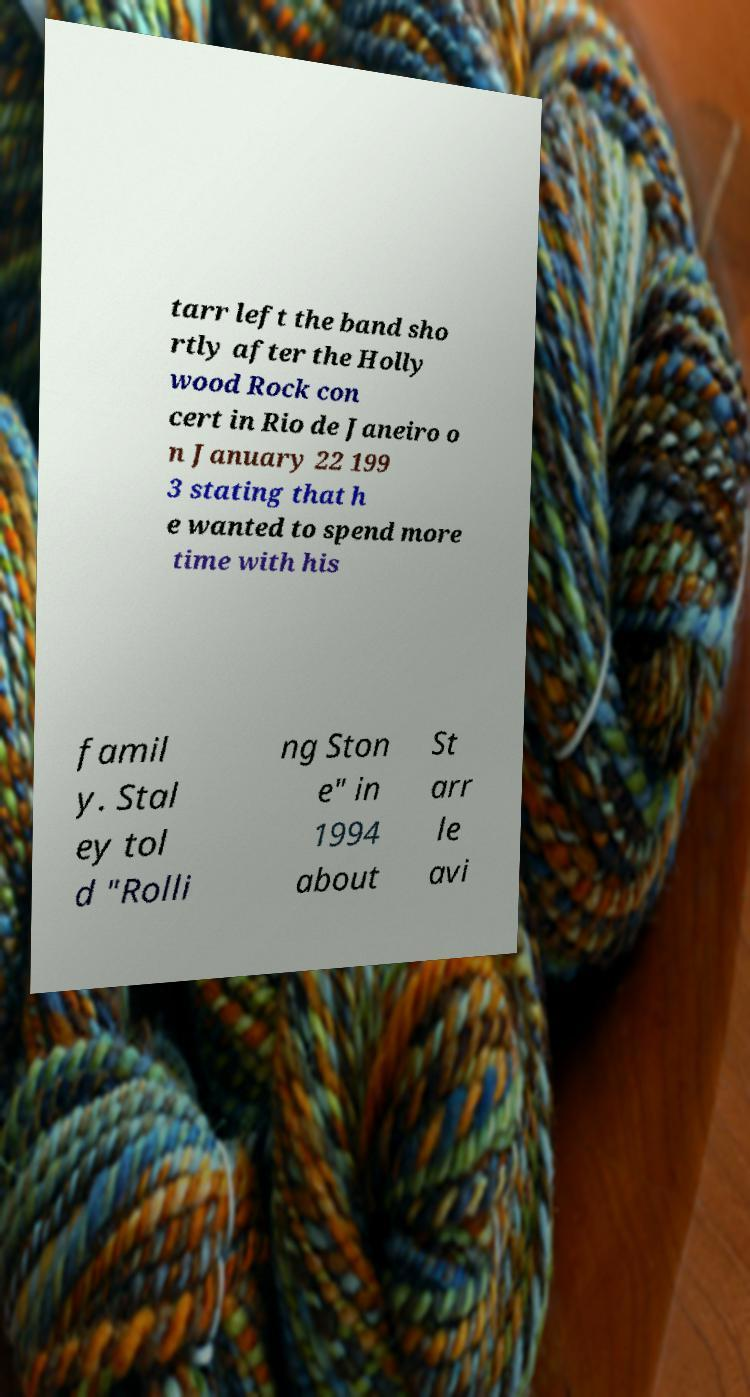Can you accurately transcribe the text from the provided image for me? tarr left the band sho rtly after the Holly wood Rock con cert in Rio de Janeiro o n January 22 199 3 stating that h e wanted to spend more time with his famil y. Stal ey tol d "Rolli ng Ston e" in 1994 about St arr le avi 